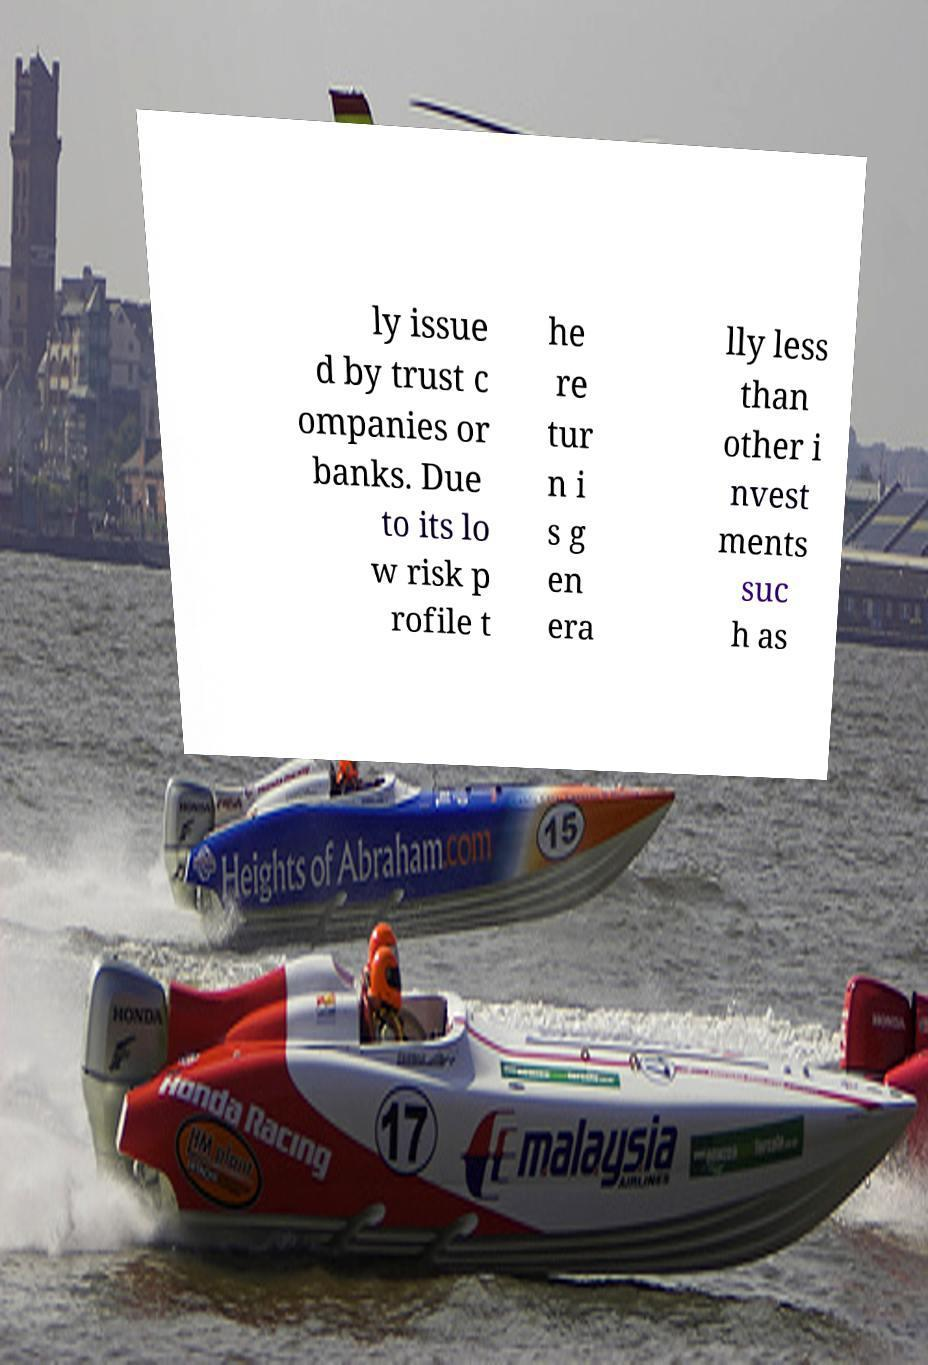Could you extract and type out the text from this image? ly issue d by trust c ompanies or banks. Due to its lo w risk p rofile t he re tur n i s g en era lly less than other i nvest ments suc h as 